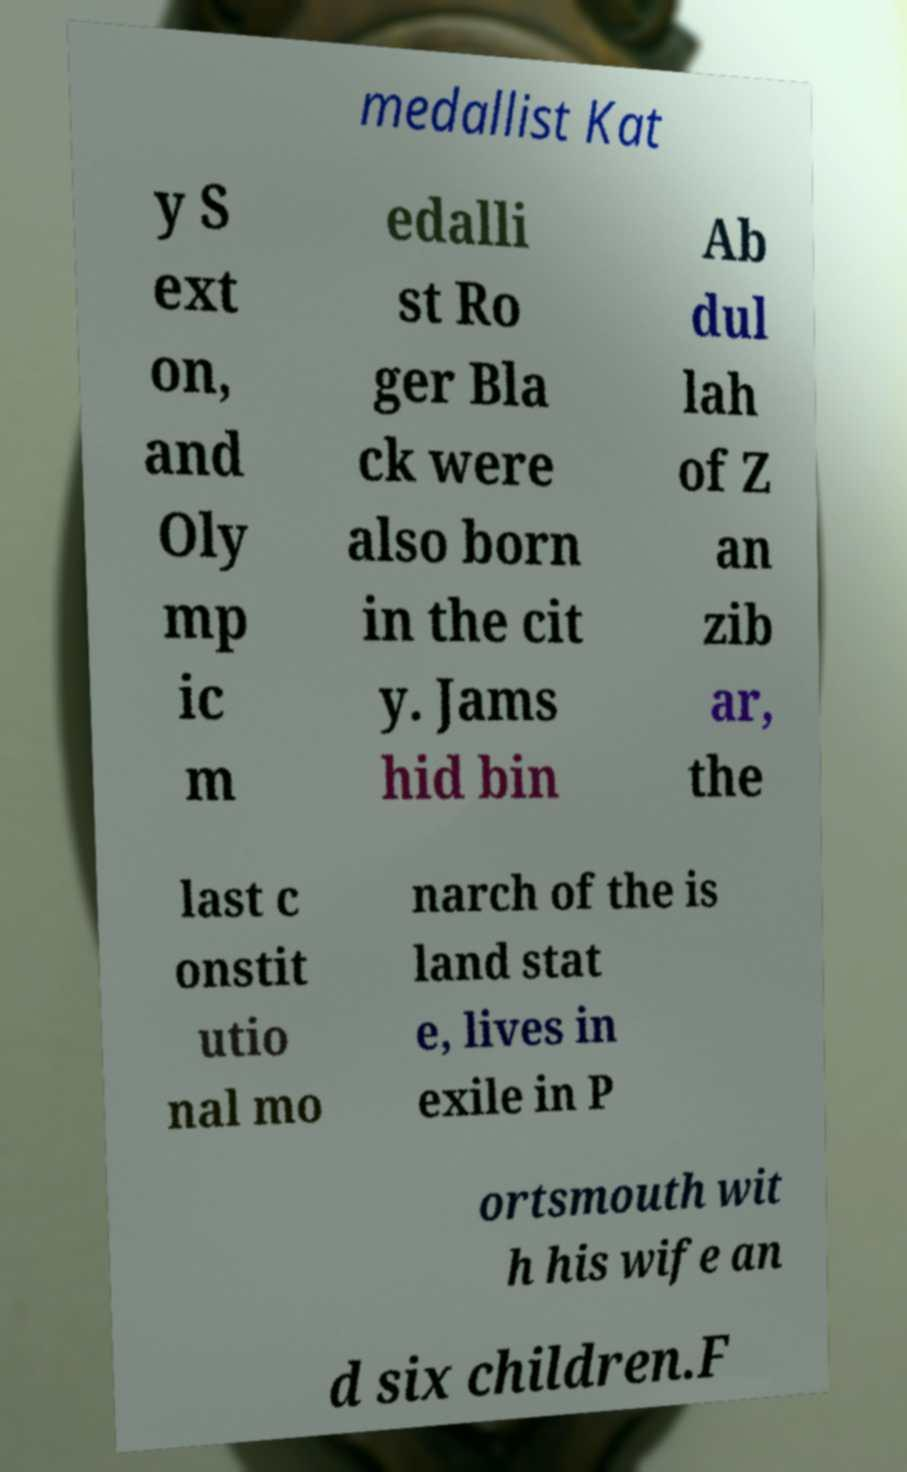Could you assist in decoding the text presented in this image and type it out clearly? medallist Kat y S ext on, and Oly mp ic m edalli st Ro ger Bla ck were also born in the cit y. Jams hid bin Ab dul lah of Z an zib ar, the last c onstit utio nal mo narch of the is land stat e, lives in exile in P ortsmouth wit h his wife an d six children.F 